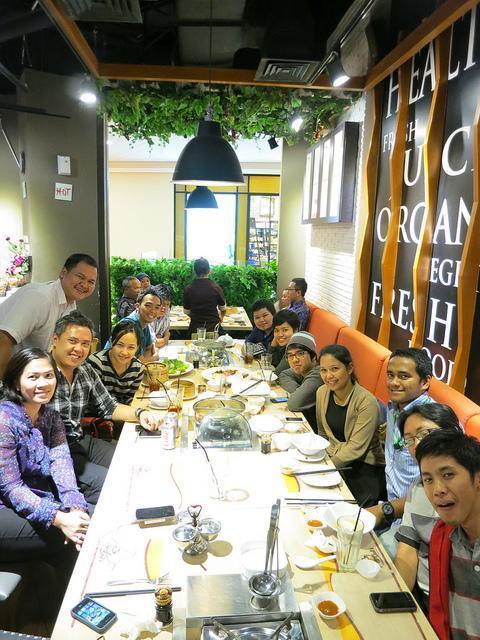How many people are there?
Give a very brief answer. 10. How many dining tables can be seen?
Give a very brief answer. 1. How many buses are there?
Give a very brief answer. 0. 